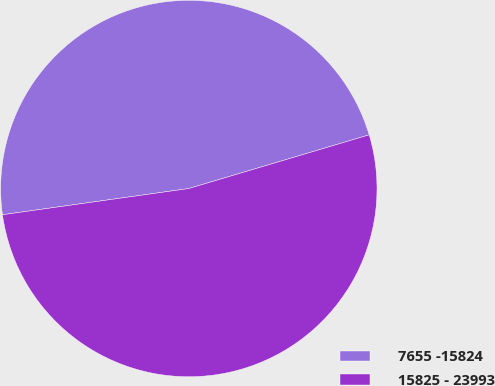Convert chart. <chart><loc_0><loc_0><loc_500><loc_500><pie_chart><fcel>7655 -15824<fcel>15825 - 23993<nl><fcel>47.62%<fcel>52.38%<nl></chart> 